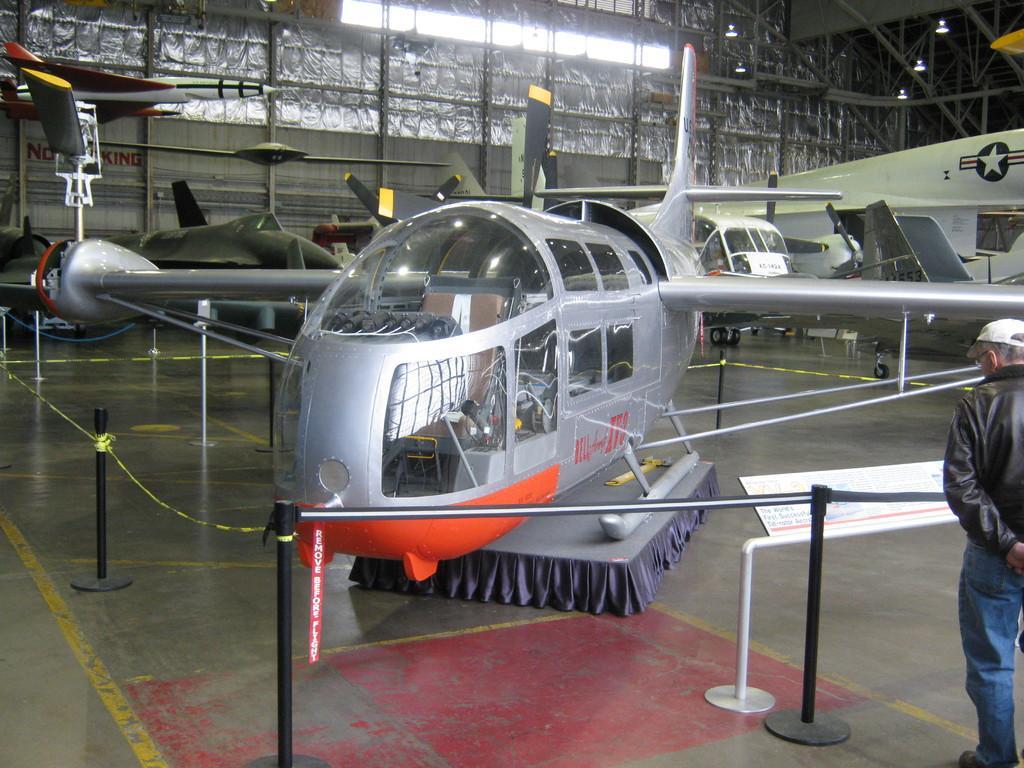Describe this image in one or two sentences. In the image I can see some planes which are in between the caution rope and also I can see a person to the side. 